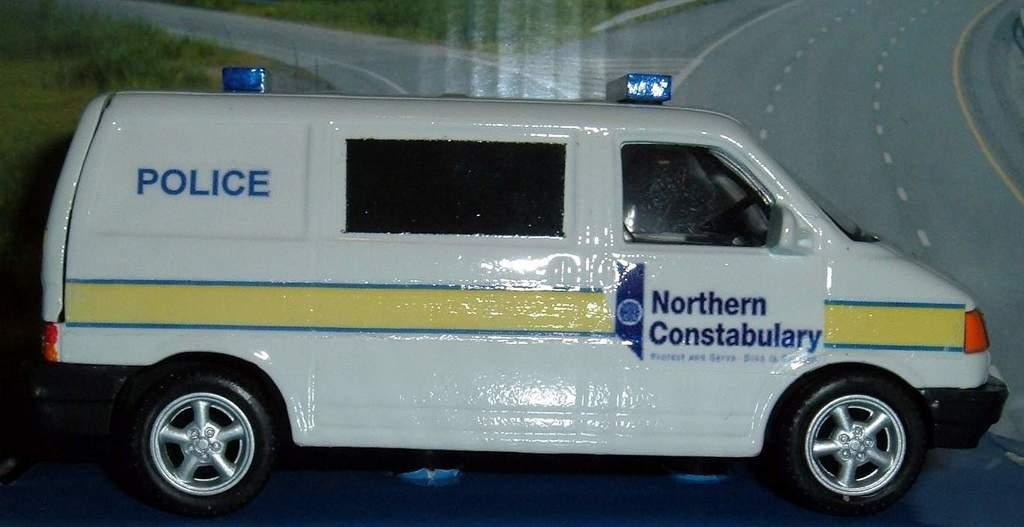<image>
Provide a brief description of the given image. a Northern Constabulary Police van is on display somewhere 